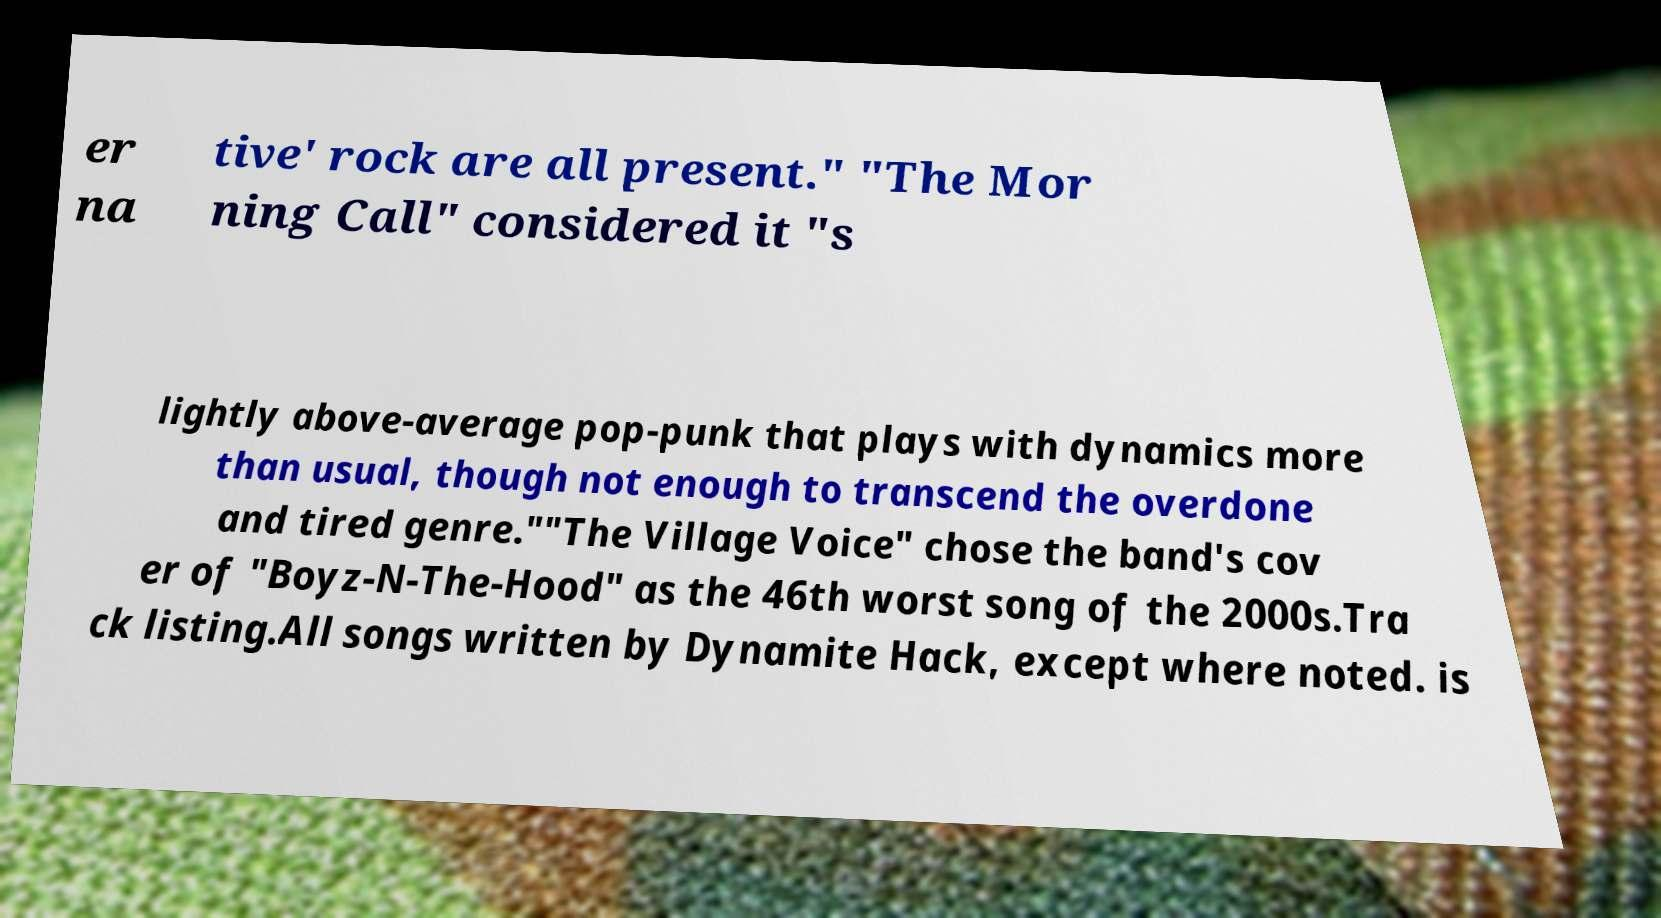Please read and relay the text visible in this image. What does it say? er na tive' rock are all present." "The Mor ning Call" considered it "s lightly above-average pop-punk that plays with dynamics more than usual, though not enough to transcend the overdone and tired genre.""The Village Voice" chose the band's cov er of "Boyz-N-The-Hood" as the 46th worst song of the 2000s.Tra ck listing.All songs written by Dynamite Hack, except where noted. is 